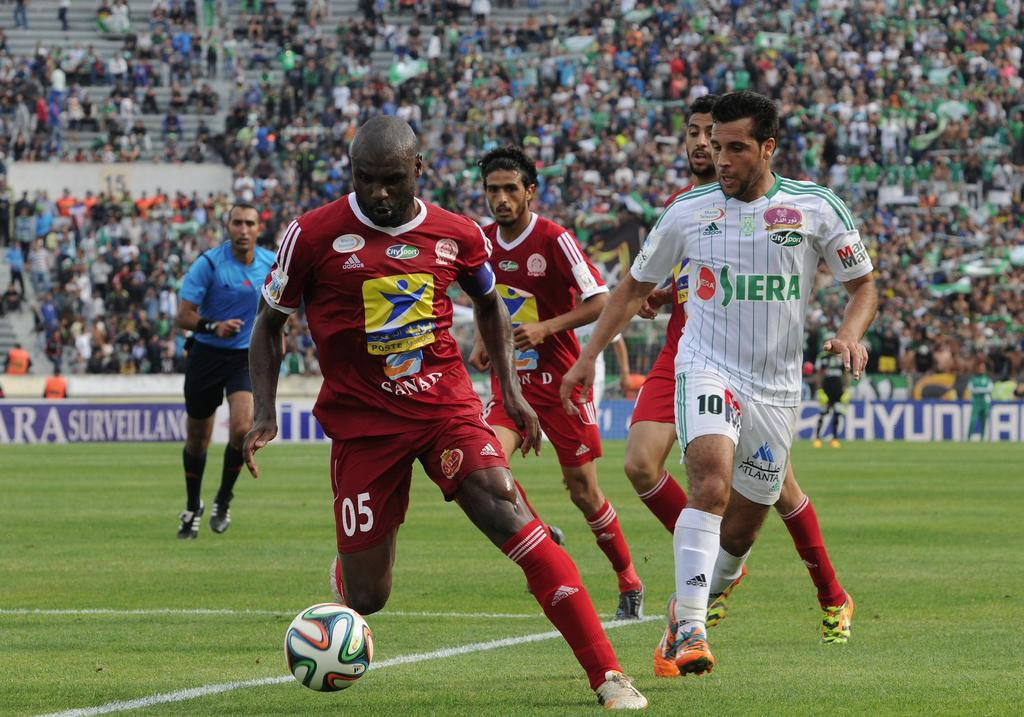What sport are the players engaged in within the image? The players are playing football in the center of the image. Can you describe the people in the background of the image? There is a group of people sitting and watching the game in the background. What type of fish can be seen swimming in the moonlit water in the image? There is no fish or moonlit water present in the image; it features a football game and spectators. 